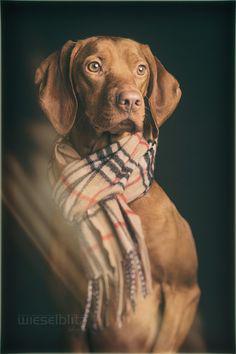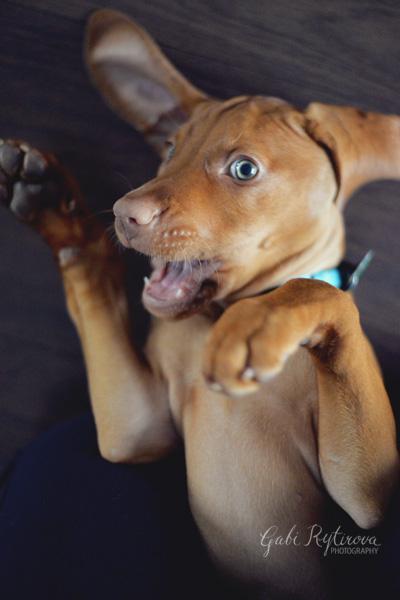The first image is the image on the left, the second image is the image on the right. For the images shown, is this caption "At least one dog is laying on a pillow." true? Answer yes or no. No. 